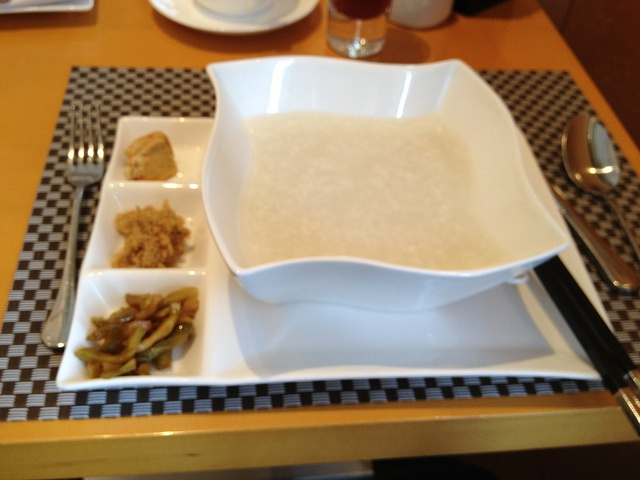Describe the objects in this image and their specific colors. I can see bowl in maroon, tan, lightgray, and darkgray tones, dining table in maroon, olive, and orange tones, knife in maroon, black, and gray tones, fork in maroon, gray, and tan tones, and spoon in maroon, gray, and black tones in this image. 